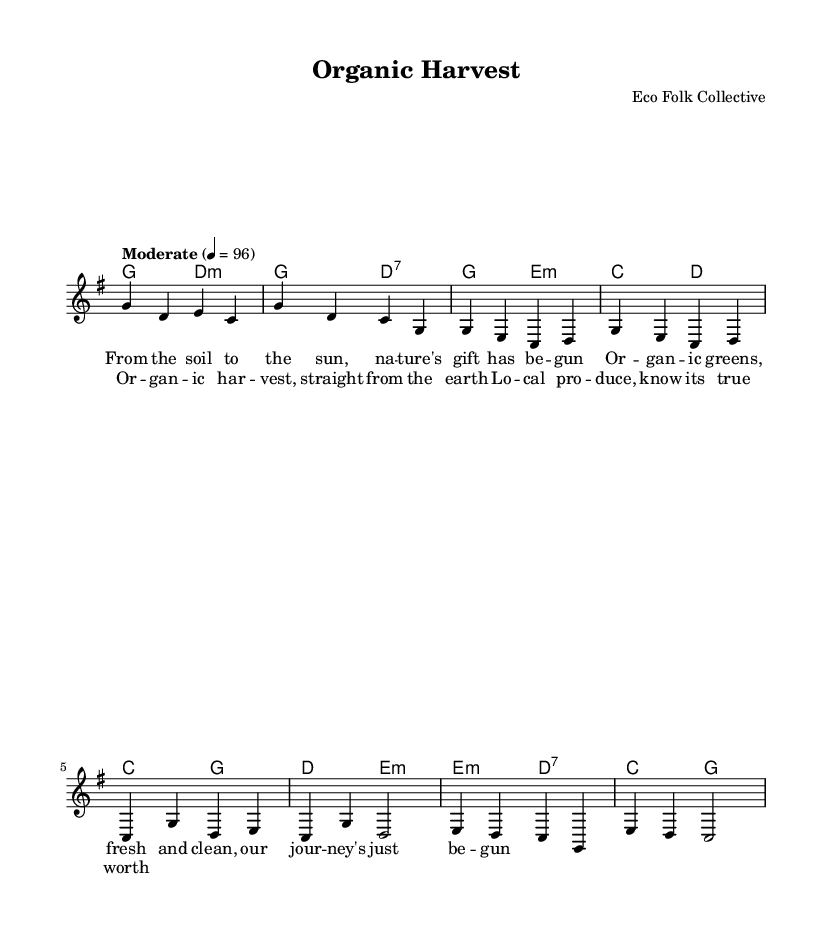What is the key signature of this music? The key signature is G major, indicated by one sharp (F#) in the music.
Answer: G major What is the time signature of this music? The time signature is 4/4, which means there are four beats in each measure, and the quarter note gets one beat.
Answer: 4/4 What is the tempo marking of this piece? The tempo marking is "Moderate," which indicates a moderate speed for the performance.
Answer: Moderate How many measures are in the intro section? The intro section consists of two measures, as seen in the notation provided.
Answer: 2 What is the repeated lyric in the chorus? The repeated lyric in the chorus is "Or -- gan -- ic har -- vest," which emphasizes the theme of organic produce.
Answer: Or -- gan -- ic har -- vest What is the chord progression for the verse section? The chord progression for the verse is G, E minor, C, D, which supports the melody and lyrical content about organic produce.
Answer: G, E minor, C, D What theme do the lyrics focus on in this piece? The lyrics focus on the theme of local and organic produce, highlighting its significance and benefits.
Answer: Local and organic produce 